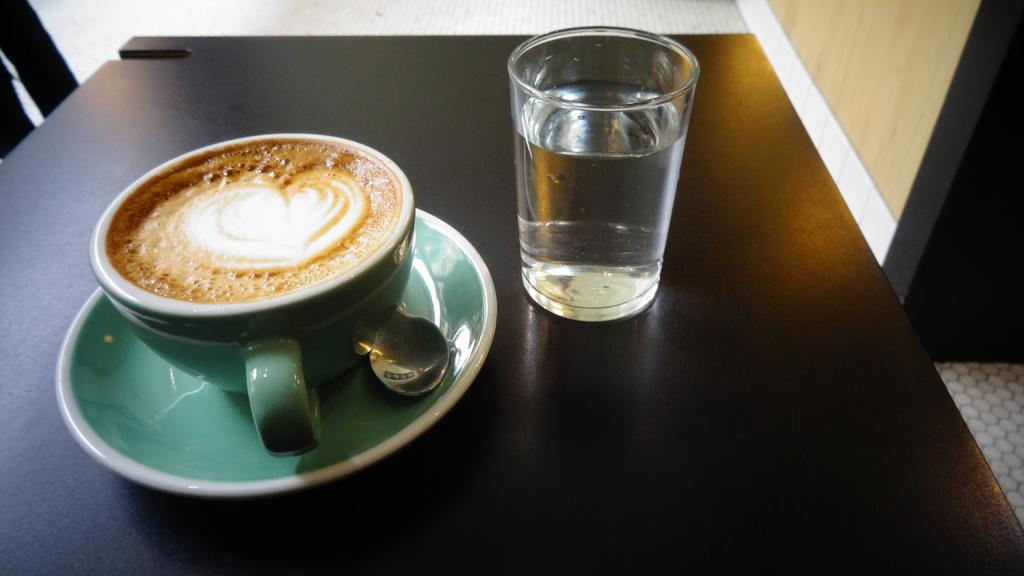What piece of furniture is present in the image? There is a table in the image. What items are on the table? There is a cup, a saucer, a spoon, and a glass on the table. What is the purpose of the saucer? The saucer is likely used to hold the cup and prevent spills. What is in the glass? The glass contains water. Where is the cactus located in the image? There is no cactus present in the image. What type of impulse can be seen affecting the glass of water in the image? There is no impulse affecting the glass of water in the image; it is stationary on the table. 